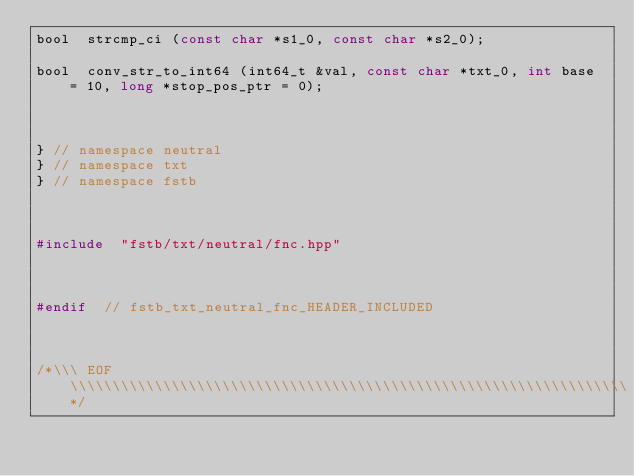<code> <loc_0><loc_0><loc_500><loc_500><_C_>bool	strcmp_ci (const char *s1_0, const char *s2_0);

bool	conv_str_to_int64 (int64_t &val, const char *txt_0, int base = 10, long *stop_pos_ptr = 0);



}	// namespace neutral
}	// namespace txt
}	// namespace fstb



#include	"fstb/txt/neutral/fnc.hpp"



#endif	// fstb_txt_neutral_fnc_HEADER_INCLUDED



/*\\\ EOF \\\\\\\\\\\\\\\\\\\\\\\\\\\\\\\\\\\\\\\\\\\\\\\\\\\\\\\\\\\\\\\\\\*/
</code> 